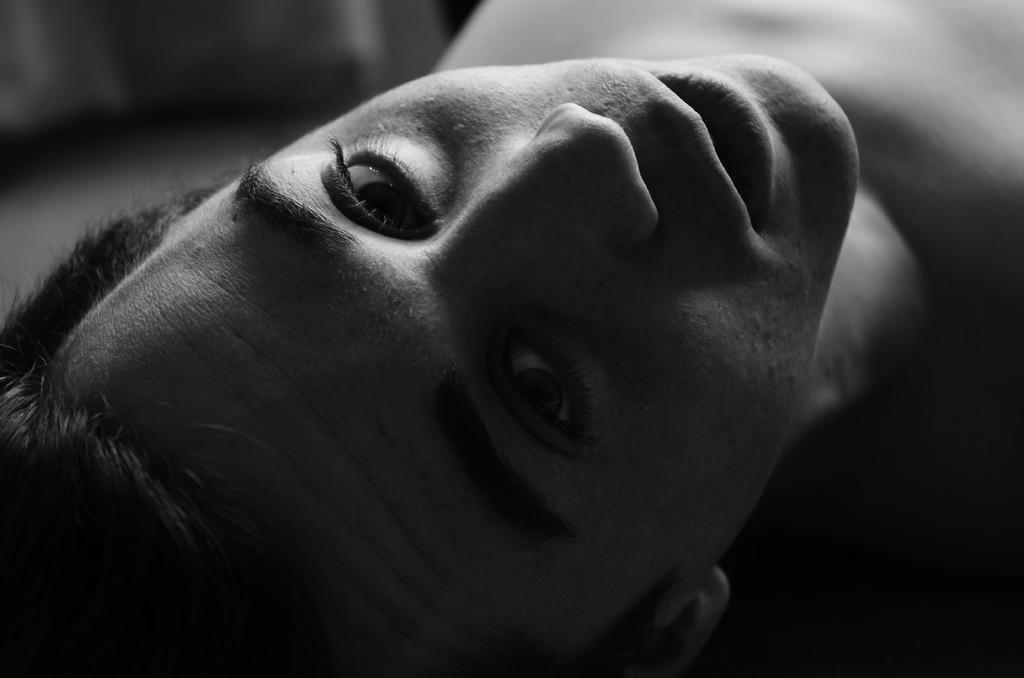What is the color scheme of the image? The image is black and white. Can you describe the main subject of the image? There is a man in the image. What type of marble is the man holding in the image? There is no marble present in the image; it is a black and white image featuring a man. What kind of sponge is the man using to clean the substance in the image? There is no sponge or substance present in the image; it only features a man in a black and white setting. 